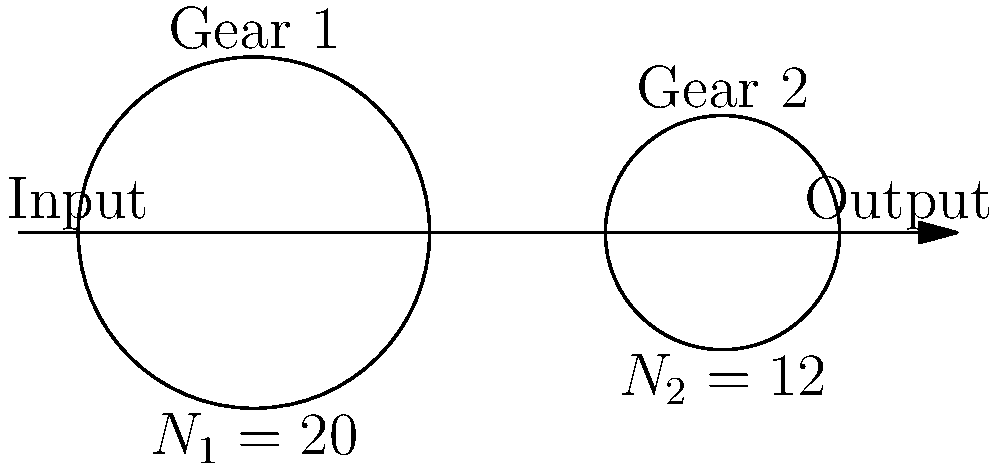In the simple gear train shown above, Gear 1 has 20 teeth and Gear 2 has 12 teeth. If the input torque on Gear 1 is 100 Nm, what is the output torque on Gear 2? How does this relate to the concept of mechanical advantage in gear systems? To solve this problem, we'll follow these steps:

1. Calculate the gear ratio:
   The gear ratio is defined as the ratio of the number of teeth on the output gear to the number of teeth on the input gear.
   Gear ratio = $\frac{N_2}{N_1} = \frac{12}{20} = 0.6$

2. Understand the relationship between gear ratio and torque:
   In a simple gear train, the ratio of output torque to input torque is inversely proportional to the gear ratio.
   $\frac{T_\text{out}}{T_\text{in}} = \frac{N_1}{N_2}$

3. Calculate the output torque:
   $T_\text{out} = T_\text{in} \times \frac{N_1}{N_2} = 100 \text{ Nm} \times \frac{20}{12} = 166.67 \text{ Nm}$

4. Relate to mechanical advantage:
   Mechanical advantage (MA) in a gear system is the ratio of output force (or torque) to input force (or torque).
   MA = $\frac{T_\text{out}}{T_\text{in}} = \frac{166.67}{100} = 1.67$

This result demonstrates that the simple gear train provides a mechanical advantage of 1.67, meaning it amplifies the input torque by a factor of 1.67. This is achieved by trading off speed for torque, as the output gear will rotate more slowly than the input gear.
Answer: Output torque: 166.67 Nm; Mechanical advantage: 1.67 